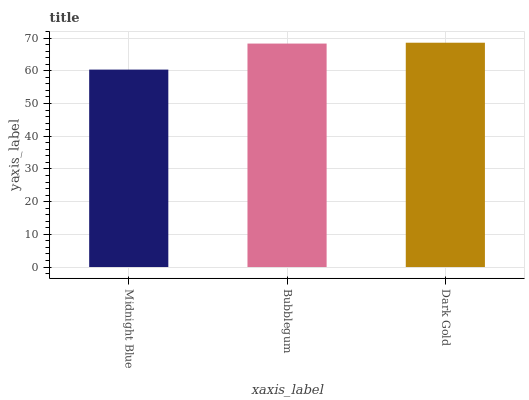Is Midnight Blue the minimum?
Answer yes or no. Yes. Is Dark Gold the maximum?
Answer yes or no. Yes. Is Bubblegum the minimum?
Answer yes or no. No. Is Bubblegum the maximum?
Answer yes or no. No. Is Bubblegum greater than Midnight Blue?
Answer yes or no. Yes. Is Midnight Blue less than Bubblegum?
Answer yes or no. Yes. Is Midnight Blue greater than Bubblegum?
Answer yes or no. No. Is Bubblegum less than Midnight Blue?
Answer yes or no. No. Is Bubblegum the high median?
Answer yes or no. Yes. Is Bubblegum the low median?
Answer yes or no. Yes. Is Midnight Blue the high median?
Answer yes or no. No. Is Midnight Blue the low median?
Answer yes or no. No. 